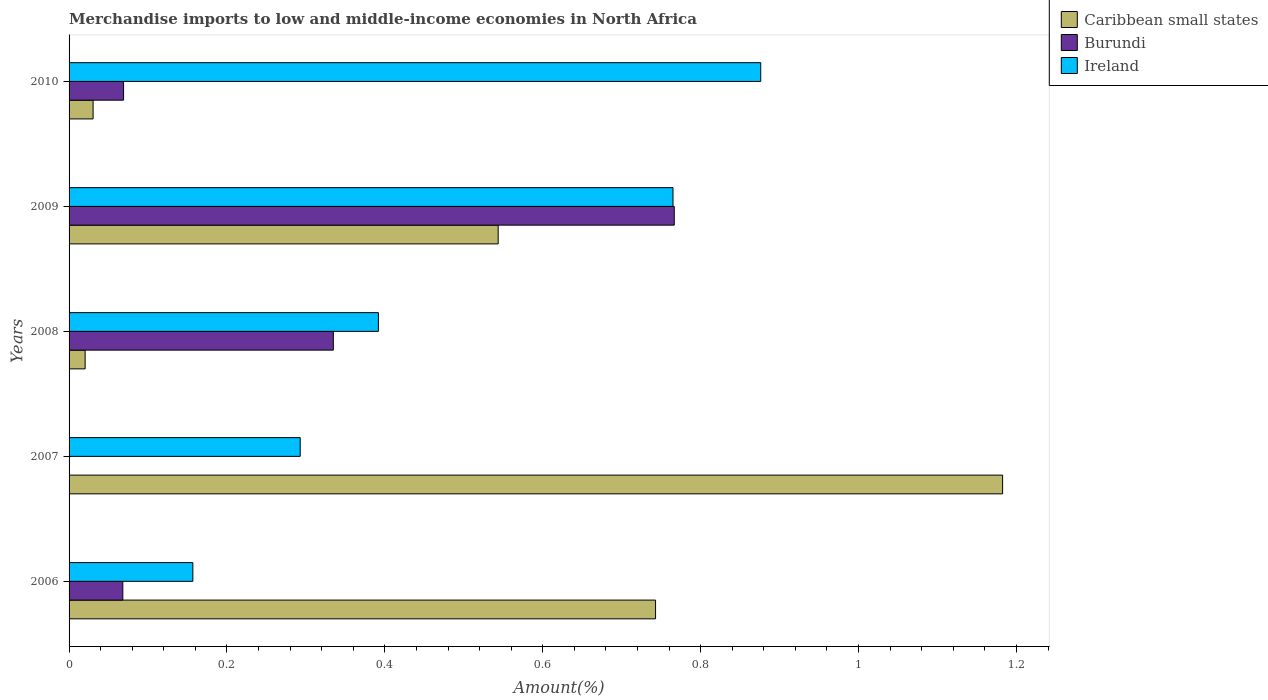How many different coloured bars are there?
Provide a short and direct response. 3. Are the number of bars on each tick of the Y-axis equal?
Provide a succinct answer. Yes. How many bars are there on the 2nd tick from the bottom?
Give a very brief answer. 3. What is the label of the 1st group of bars from the top?
Your answer should be compact. 2010. In how many cases, is the number of bars for a given year not equal to the number of legend labels?
Provide a succinct answer. 0. What is the percentage of amount earned from merchandise imports in Ireland in 2009?
Give a very brief answer. 0.76. Across all years, what is the maximum percentage of amount earned from merchandise imports in Burundi?
Keep it short and to the point. 0.77. Across all years, what is the minimum percentage of amount earned from merchandise imports in Burundi?
Keep it short and to the point. 2.88933667223069e-5. In which year was the percentage of amount earned from merchandise imports in Burundi maximum?
Keep it short and to the point. 2009. In which year was the percentage of amount earned from merchandise imports in Caribbean small states minimum?
Make the answer very short. 2008. What is the total percentage of amount earned from merchandise imports in Burundi in the graph?
Your response must be concise. 1.24. What is the difference between the percentage of amount earned from merchandise imports in Burundi in 2008 and that in 2009?
Provide a succinct answer. -0.43. What is the difference between the percentage of amount earned from merchandise imports in Ireland in 2008 and the percentage of amount earned from merchandise imports in Burundi in 2007?
Make the answer very short. 0.39. What is the average percentage of amount earned from merchandise imports in Ireland per year?
Give a very brief answer. 0.5. In the year 2010, what is the difference between the percentage of amount earned from merchandise imports in Ireland and percentage of amount earned from merchandise imports in Caribbean small states?
Keep it short and to the point. 0.85. In how many years, is the percentage of amount earned from merchandise imports in Ireland greater than 1.12 %?
Your answer should be compact. 0. What is the ratio of the percentage of amount earned from merchandise imports in Caribbean small states in 2006 to that in 2010?
Provide a short and direct response. 24.42. Is the percentage of amount earned from merchandise imports in Caribbean small states in 2008 less than that in 2010?
Offer a very short reply. Yes. What is the difference between the highest and the second highest percentage of amount earned from merchandise imports in Burundi?
Your answer should be very brief. 0.43. What is the difference between the highest and the lowest percentage of amount earned from merchandise imports in Caribbean small states?
Provide a succinct answer. 1.16. In how many years, is the percentage of amount earned from merchandise imports in Burundi greater than the average percentage of amount earned from merchandise imports in Burundi taken over all years?
Make the answer very short. 2. Is the sum of the percentage of amount earned from merchandise imports in Ireland in 2006 and 2007 greater than the maximum percentage of amount earned from merchandise imports in Burundi across all years?
Your answer should be very brief. No. What does the 1st bar from the top in 2010 represents?
Ensure brevity in your answer.  Ireland. What does the 2nd bar from the bottom in 2008 represents?
Ensure brevity in your answer.  Burundi. How many bars are there?
Your answer should be very brief. 15. Are all the bars in the graph horizontal?
Keep it short and to the point. Yes. Are the values on the major ticks of X-axis written in scientific E-notation?
Offer a very short reply. No. Does the graph contain grids?
Make the answer very short. No. What is the title of the graph?
Offer a very short reply. Merchandise imports to low and middle-income economies in North Africa. What is the label or title of the X-axis?
Provide a succinct answer. Amount(%). What is the label or title of the Y-axis?
Offer a very short reply. Years. What is the Amount(%) of Caribbean small states in 2006?
Your response must be concise. 0.74. What is the Amount(%) in Burundi in 2006?
Your answer should be very brief. 0.07. What is the Amount(%) of Ireland in 2006?
Make the answer very short. 0.16. What is the Amount(%) of Caribbean small states in 2007?
Provide a succinct answer. 1.18. What is the Amount(%) of Burundi in 2007?
Provide a succinct answer. 2.88933667223069e-5. What is the Amount(%) in Ireland in 2007?
Give a very brief answer. 0.29. What is the Amount(%) of Caribbean small states in 2008?
Offer a very short reply. 0.02. What is the Amount(%) in Burundi in 2008?
Keep it short and to the point. 0.33. What is the Amount(%) of Ireland in 2008?
Provide a succinct answer. 0.39. What is the Amount(%) in Caribbean small states in 2009?
Offer a terse response. 0.54. What is the Amount(%) of Burundi in 2009?
Your response must be concise. 0.77. What is the Amount(%) in Ireland in 2009?
Provide a short and direct response. 0.76. What is the Amount(%) in Caribbean small states in 2010?
Offer a very short reply. 0.03. What is the Amount(%) in Burundi in 2010?
Make the answer very short. 0.07. What is the Amount(%) in Ireland in 2010?
Provide a succinct answer. 0.88. Across all years, what is the maximum Amount(%) in Caribbean small states?
Your response must be concise. 1.18. Across all years, what is the maximum Amount(%) in Burundi?
Make the answer very short. 0.77. Across all years, what is the maximum Amount(%) in Ireland?
Your answer should be very brief. 0.88. Across all years, what is the minimum Amount(%) in Caribbean small states?
Provide a succinct answer. 0.02. Across all years, what is the minimum Amount(%) in Burundi?
Keep it short and to the point. 2.88933667223069e-5. Across all years, what is the minimum Amount(%) in Ireland?
Your response must be concise. 0.16. What is the total Amount(%) in Caribbean small states in the graph?
Offer a very short reply. 2.52. What is the total Amount(%) in Burundi in the graph?
Your answer should be very brief. 1.24. What is the total Amount(%) of Ireland in the graph?
Offer a very short reply. 2.48. What is the difference between the Amount(%) of Caribbean small states in 2006 and that in 2007?
Your answer should be very brief. -0.44. What is the difference between the Amount(%) of Burundi in 2006 and that in 2007?
Ensure brevity in your answer.  0.07. What is the difference between the Amount(%) of Ireland in 2006 and that in 2007?
Your answer should be very brief. -0.14. What is the difference between the Amount(%) in Caribbean small states in 2006 and that in 2008?
Offer a very short reply. 0.72. What is the difference between the Amount(%) of Burundi in 2006 and that in 2008?
Provide a succinct answer. -0.27. What is the difference between the Amount(%) in Ireland in 2006 and that in 2008?
Ensure brevity in your answer.  -0.23. What is the difference between the Amount(%) in Caribbean small states in 2006 and that in 2009?
Your response must be concise. 0.2. What is the difference between the Amount(%) in Burundi in 2006 and that in 2009?
Provide a short and direct response. -0.7. What is the difference between the Amount(%) in Ireland in 2006 and that in 2009?
Provide a short and direct response. -0.61. What is the difference between the Amount(%) of Caribbean small states in 2006 and that in 2010?
Provide a succinct answer. 0.71. What is the difference between the Amount(%) in Burundi in 2006 and that in 2010?
Make the answer very short. -0. What is the difference between the Amount(%) of Ireland in 2006 and that in 2010?
Give a very brief answer. -0.72. What is the difference between the Amount(%) in Caribbean small states in 2007 and that in 2008?
Make the answer very short. 1.16. What is the difference between the Amount(%) in Burundi in 2007 and that in 2008?
Keep it short and to the point. -0.33. What is the difference between the Amount(%) in Ireland in 2007 and that in 2008?
Your response must be concise. -0.1. What is the difference between the Amount(%) in Caribbean small states in 2007 and that in 2009?
Offer a terse response. 0.64. What is the difference between the Amount(%) of Burundi in 2007 and that in 2009?
Ensure brevity in your answer.  -0.77. What is the difference between the Amount(%) in Ireland in 2007 and that in 2009?
Make the answer very short. -0.47. What is the difference between the Amount(%) in Caribbean small states in 2007 and that in 2010?
Keep it short and to the point. 1.15. What is the difference between the Amount(%) in Burundi in 2007 and that in 2010?
Offer a very short reply. -0.07. What is the difference between the Amount(%) in Ireland in 2007 and that in 2010?
Make the answer very short. -0.58. What is the difference between the Amount(%) in Caribbean small states in 2008 and that in 2009?
Make the answer very short. -0.52. What is the difference between the Amount(%) of Burundi in 2008 and that in 2009?
Give a very brief answer. -0.43. What is the difference between the Amount(%) of Ireland in 2008 and that in 2009?
Ensure brevity in your answer.  -0.37. What is the difference between the Amount(%) of Caribbean small states in 2008 and that in 2010?
Offer a very short reply. -0.01. What is the difference between the Amount(%) of Burundi in 2008 and that in 2010?
Offer a very short reply. 0.27. What is the difference between the Amount(%) in Ireland in 2008 and that in 2010?
Your response must be concise. -0.48. What is the difference between the Amount(%) of Caribbean small states in 2009 and that in 2010?
Your response must be concise. 0.51. What is the difference between the Amount(%) in Burundi in 2009 and that in 2010?
Make the answer very short. 0.7. What is the difference between the Amount(%) in Ireland in 2009 and that in 2010?
Ensure brevity in your answer.  -0.11. What is the difference between the Amount(%) in Caribbean small states in 2006 and the Amount(%) in Burundi in 2007?
Provide a short and direct response. 0.74. What is the difference between the Amount(%) in Caribbean small states in 2006 and the Amount(%) in Ireland in 2007?
Provide a succinct answer. 0.45. What is the difference between the Amount(%) in Burundi in 2006 and the Amount(%) in Ireland in 2007?
Keep it short and to the point. -0.22. What is the difference between the Amount(%) in Caribbean small states in 2006 and the Amount(%) in Burundi in 2008?
Provide a succinct answer. 0.41. What is the difference between the Amount(%) of Caribbean small states in 2006 and the Amount(%) of Ireland in 2008?
Keep it short and to the point. 0.35. What is the difference between the Amount(%) of Burundi in 2006 and the Amount(%) of Ireland in 2008?
Your response must be concise. -0.32. What is the difference between the Amount(%) of Caribbean small states in 2006 and the Amount(%) of Burundi in 2009?
Ensure brevity in your answer.  -0.02. What is the difference between the Amount(%) of Caribbean small states in 2006 and the Amount(%) of Ireland in 2009?
Provide a succinct answer. -0.02. What is the difference between the Amount(%) in Burundi in 2006 and the Amount(%) in Ireland in 2009?
Offer a terse response. -0.7. What is the difference between the Amount(%) in Caribbean small states in 2006 and the Amount(%) in Burundi in 2010?
Provide a short and direct response. 0.67. What is the difference between the Amount(%) in Caribbean small states in 2006 and the Amount(%) in Ireland in 2010?
Offer a terse response. -0.13. What is the difference between the Amount(%) in Burundi in 2006 and the Amount(%) in Ireland in 2010?
Keep it short and to the point. -0.81. What is the difference between the Amount(%) in Caribbean small states in 2007 and the Amount(%) in Burundi in 2008?
Ensure brevity in your answer.  0.85. What is the difference between the Amount(%) of Caribbean small states in 2007 and the Amount(%) of Ireland in 2008?
Offer a very short reply. 0.79. What is the difference between the Amount(%) in Burundi in 2007 and the Amount(%) in Ireland in 2008?
Ensure brevity in your answer.  -0.39. What is the difference between the Amount(%) in Caribbean small states in 2007 and the Amount(%) in Burundi in 2009?
Offer a very short reply. 0.42. What is the difference between the Amount(%) of Caribbean small states in 2007 and the Amount(%) of Ireland in 2009?
Your answer should be very brief. 0.42. What is the difference between the Amount(%) in Burundi in 2007 and the Amount(%) in Ireland in 2009?
Keep it short and to the point. -0.76. What is the difference between the Amount(%) in Caribbean small states in 2007 and the Amount(%) in Burundi in 2010?
Your response must be concise. 1.11. What is the difference between the Amount(%) in Caribbean small states in 2007 and the Amount(%) in Ireland in 2010?
Your answer should be very brief. 0.31. What is the difference between the Amount(%) of Burundi in 2007 and the Amount(%) of Ireland in 2010?
Offer a terse response. -0.88. What is the difference between the Amount(%) of Caribbean small states in 2008 and the Amount(%) of Burundi in 2009?
Your response must be concise. -0.75. What is the difference between the Amount(%) of Caribbean small states in 2008 and the Amount(%) of Ireland in 2009?
Provide a succinct answer. -0.74. What is the difference between the Amount(%) of Burundi in 2008 and the Amount(%) of Ireland in 2009?
Ensure brevity in your answer.  -0.43. What is the difference between the Amount(%) of Caribbean small states in 2008 and the Amount(%) of Burundi in 2010?
Provide a succinct answer. -0.05. What is the difference between the Amount(%) of Caribbean small states in 2008 and the Amount(%) of Ireland in 2010?
Provide a short and direct response. -0.86. What is the difference between the Amount(%) in Burundi in 2008 and the Amount(%) in Ireland in 2010?
Your answer should be very brief. -0.54. What is the difference between the Amount(%) of Caribbean small states in 2009 and the Amount(%) of Burundi in 2010?
Make the answer very short. 0.47. What is the difference between the Amount(%) of Caribbean small states in 2009 and the Amount(%) of Ireland in 2010?
Provide a short and direct response. -0.33. What is the difference between the Amount(%) in Burundi in 2009 and the Amount(%) in Ireland in 2010?
Provide a succinct answer. -0.11. What is the average Amount(%) in Caribbean small states per year?
Ensure brevity in your answer.  0.5. What is the average Amount(%) in Burundi per year?
Keep it short and to the point. 0.25. What is the average Amount(%) of Ireland per year?
Provide a short and direct response. 0.5. In the year 2006, what is the difference between the Amount(%) of Caribbean small states and Amount(%) of Burundi?
Give a very brief answer. 0.67. In the year 2006, what is the difference between the Amount(%) in Caribbean small states and Amount(%) in Ireland?
Provide a succinct answer. 0.59. In the year 2006, what is the difference between the Amount(%) of Burundi and Amount(%) of Ireland?
Provide a succinct answer. -0.09. In the year 2007, what is the difference between the Amount(%) of Caribbean small states and Amount(%) of Burundi?
Provide a short and direct response. 1.18. In the year 2007, what is the difference between the Amount(%) of Caribbean small states and Amount(%) of Ireland?
Provide a short and direct response. 0.89. In the year 2007, what is the difference between the Amount(%) in Burundi and Amount(%) in Ireland?
Your response must be concise. -0.29. In the year 2008, what is the difference between the Amount(%) in Caribbean small states and Amount(%) in Burundi?
Provide a short and direct response. -0.31. In the year 2008, what is the difference between the Amount(%) of Caribbean small states and Amount(%) of Ireland?
Give a very brief answer. -0.37. In the year 2008, what is the difference between the Amount(%) in Burundi and Amount(%) in Ireland?
Give a very brief answer. -0.06. In the year 2009, what is the difference between the Amount(%) of Caribbean small states and Amount(%) of Burundi?
Your answer should be compact. -0.22. In the year 2009, what is the difference between the Amount(%) of Caribbean small states and Amount(%) of Ireland?
Make the answer very short. -0.22. In the year 2009, what is the difference between the Amount(%) in Burundi and Amount(%) in Ireland?
Offer a terse response. 0. In the year 2010, what is the difference between the Amount(%) of Caribbean small states and Amount(%) of Burundi?
Make the answer very short. -0.04. In the year 2010, what is the difference between the Amount(%) of Caribbean small states and Amount(%) of Ireland?
Offer a very short reply. -0.85. In the year 2010, what is the difference between the Amount(%) of Burundi and Amount(%) of Ireland?
Offer a terse response. -0.81. What is the ratio of the Amount(%) of Caribbean small states in 2006 to that in 2007?
Your response must be concise. 0.63. What is the ratio of the Amount(%) of Burundi in 2006 to that in 2007?
Provide a short and direct response. 2355.77. What is the ratio of the Amount(%) in Ireland in 2006 to that in 2007?
Offer a terse response. 0.54. What is the ratio of the Amount(%) of Caribbean small states in 2006 to that in 2008?
Your response must be concise. 36.51. What is the ratio of the Amount(%) in Burundi in 2006 to that in 2008?
Your answer should be very brief. 0.2. What is the ratio of the Amount(%) of Ireland in 2006 to that in 2008?
Provide a short and direct response. 0.4. What is the ratio of the Amount(%) of Caribbean small states in 2006 to that in 2009?
Provide a short and direct response. 1.37. What is the ratio of the Amount(%) in Burundi in 2006 to that in 2009?
Your answer should be very brief. 0.09. What is the ratio of the Amount(%) of Ireland in 2006 to that in 2009?
Your response must be concise. 0.2. What is the ratio of the Amount(%) of Caribbean small states in 2006 to that in 2010?
Provide a short and direct response. 24.42. What is the ratio of the Amount(%) in Burundi in 2006 to that in 2010?
Provide a short and direct response. 0.99. What is the ratio of the Amount(%) of Ireland in 2006 to that in 2010?
Your answer should be compact. 0.18. What is the ratio of the Amount(%) of Caribbean small states in 2007 to that in 2008?
Your response must be concise. 58.11. What is the ratio of the Amount(%) in Burundi in 2007 to that in 2008?
Your answer should be compact. 0. What is the ratio of the Amount(%) in Ireland in 2007 to that in 2008?
Offer a terse response. 0.75. What is the ratio of the Amount(%) of Caribbean small states in 2007 to that in 2009?
Your answer should be compact. 2.18. What is the ratio of the Amount(%) of Ireland in 2007 to that in 2009?
Make the answer very short. 0.38. What is the ratio of the Amount(%) in Caribbean small states in 2007 to that in 2010?
Keep it short and to the point. 38.86. What is the ratio of the Amount(%) of Ireland in 2007 to that in 2010?
Provide a short and direct response. 0.33. What is the ratio of the Amount(%) in Caribbean small states in 2008 to that in 2009?
Your answer should be compact. 0.04. What is the ratio of the Amount(%) in Burundi in 2008 to that in 2009?
Provide a short and direct response. 0.44. What is the ratio of the Amount(%) in Ireland in 2008 to that in 2009?
Keep it short and to the point. 0.51. What is the ratio of the Amount(%) in Caribbean small states in 2008 to that in 2010?
Provide a succinct answer. 0.67. What is the ratio of the Amount(%) in Burundi in 2008 to that in 2010?
Keep it short and to the point. 4.85. What is the ratio of the Amount(%) of Ireland in 2008 to that in 2010?
Provide a short and direct response. 0.45. What is the ratio of the Amount(%) of Caribbean small states in 2009 to that in 2010?
Provide a succinct answer. 17.86. What is the ratio of the Amount(%) in Burundi in 2009 to that in 2010?
Your answer should be compact. 11.11. What is the ratio of the Amount(%) of Ireland in 2009 to that in 2010?
Your answer should be very brief. 0.87. What is the difference between the highest and the second highest Amount(%) of Caribbean small states?
Your answer should be very brief. 0.44. What is the difference between the highest and the second highest Amount(%) in Burundi?
Your answer should be very brief. 0.43. What is the difference between the highest and the lowest Amount(%) of Caribbean small states?
Offer a very short reply. 1.16. What is the difference between the highest and the lowest Amount(%) in Burundi?
Offer a very short reply. 0.77. What is the difference between the highest and the lowest Amount(%) of Ireland?
Your answer should be very brief. 0.72. 